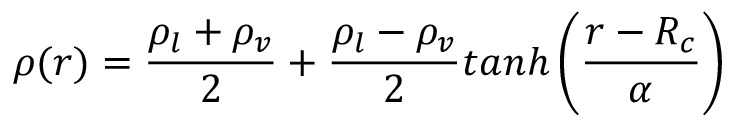<formula> <loc_0><loc_0><loc_500><loc_500>\rho ( r ) = \frac { \rho _ { l } + \rho _ { v } } { 2 } + \frac { \rho _ { l } - \rho _ { v } } { 2 } t a n h \left ( \frac { r - R _ { c } } { \alpha } \right )</formula> 